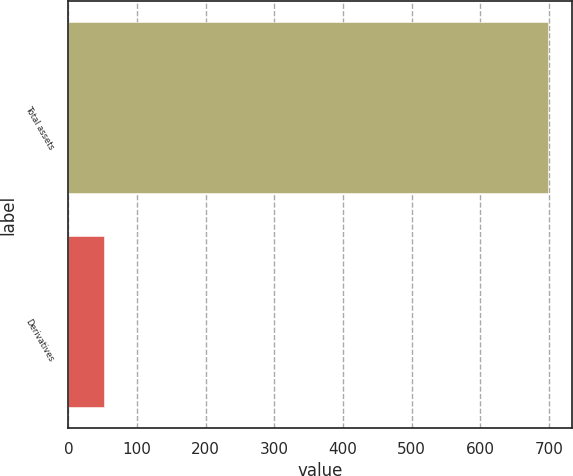<chart> <loc_0><loc_0><loc_500><loc_500><bar_chart><fcel>Total assets<fcel>Derivatives<nl><fcel>699<fcel>52<nl></chart> 